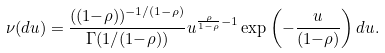Convert formula to latex. <formula><loc_0><loc_0><loc_500><loc_500>\nu ( d u ) = \frac { ( ( 1 { - } \rho ) ) ^ { - 1 / ( 1 { - } \rho ) } } { \Gamma ( 1 / ( 1 { - } \rho ) ) } u ^ { \frac { \rho } { 1 - \rho } - 1 } \exp \left ( { - } \frac { u } { ( 1 { - } \rho ) } \right ) d u .</formula> 